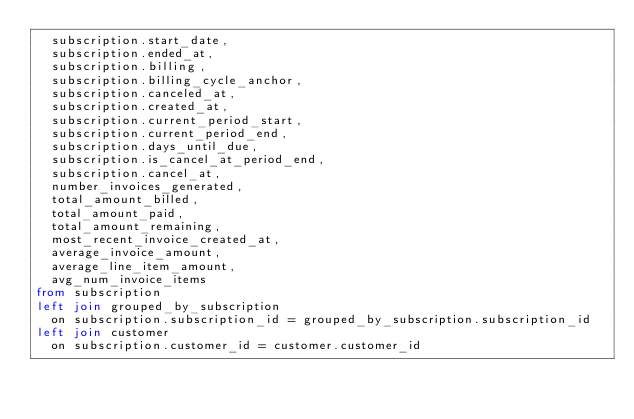Convert code to text. <code><loc_0><loc_0><loc_500><loc_500><_SQL_>  subscription.start_date,
  subscription.ended_at,
  subscription.billing,
  subscription.billing_cycle_anchor,
  subscription.canceled_at,
  subscription.created_at,
  subscription.current_period_start,
  subscription.current_period_end,
  subscription.days_until_due,
  subscription.is_cancel_at_period_end,
  subscription.cancel_at,
  number_invoices_generated,
  total_amount_billed,
  total_amount_paid,
  total_amount_remaining,
  most_recent_invoice_created_at,
  average_invoice_amount,
  average_line_item_amount,
  avg_num_invoice_items
from subscription
left join grouped_by_subscription 
  on subscription.subscription_id = grouped_by_subscription.subscription_id
left join customer 
  on subscription.customer_id = customer.customer_id
</code> 